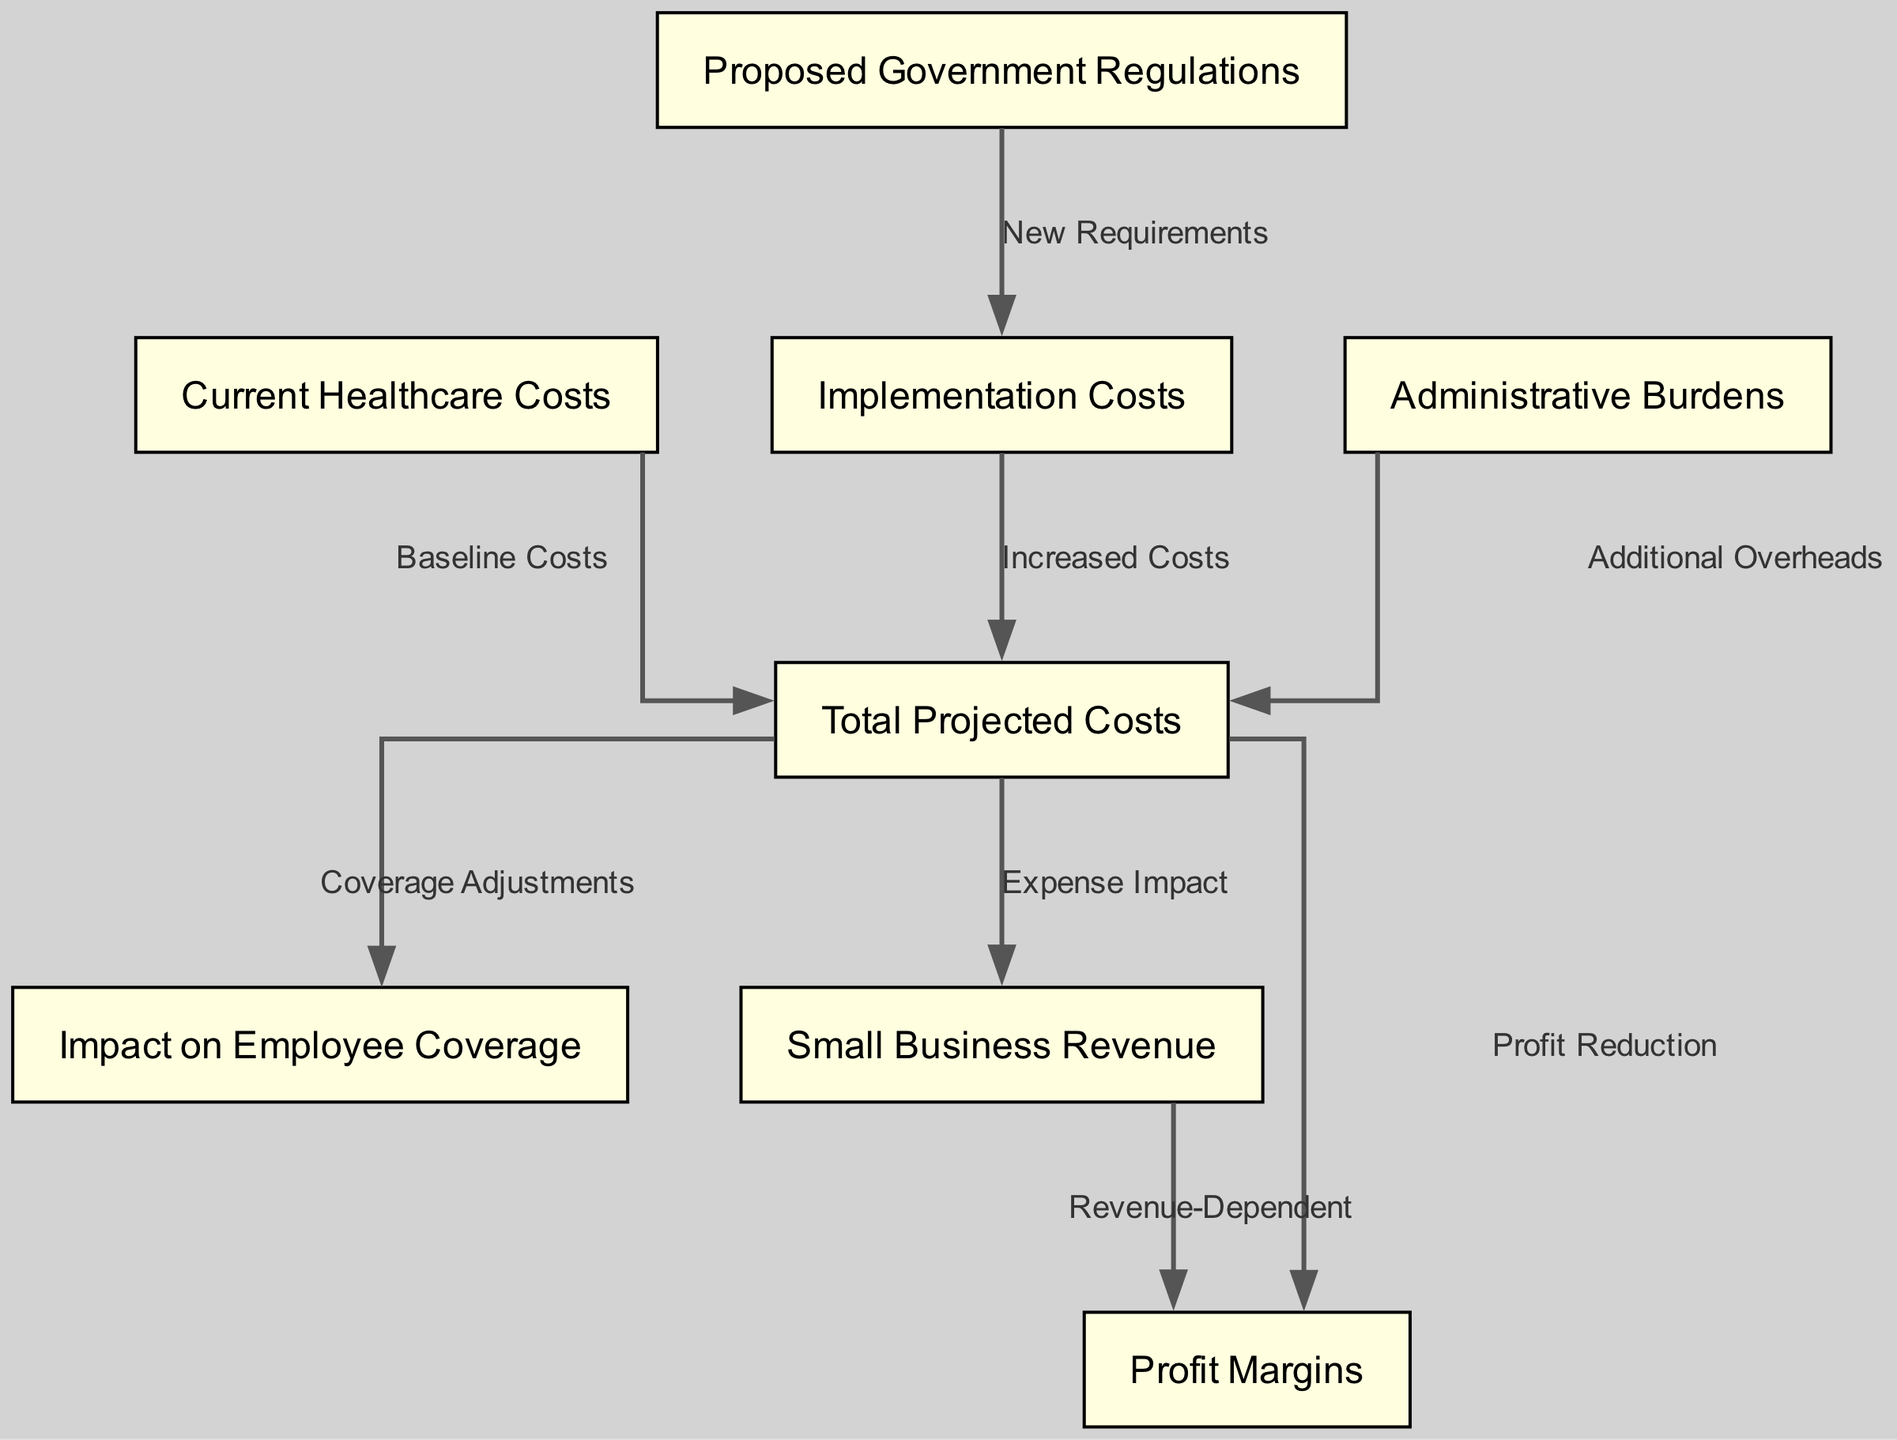What are the three main components leading to total projected costs? The diagram shows that total projected costs arise from current healthcare costs and the implementation costs from proposed government regulations and administrative burdens.
Answer: Current healthcare costs, implementation costs, administrative burdens How many nodes are present in the diagram? By counting the nodes listed in the diagram structure, we find there are eight distinct nodes represented.
Answer: Eight What does "new requirements" connect to in the diagram? The label "new requirements" indicates a connection from proposed government regulations to implementation costs, showing a direct relationship.
Answer: Implementation costs Which node signifies the adjustments made in employee coverage? The total projected costs feed into the "impact on employee coverage," indicating that adjustments occur as a result of total projected costs.
Answer: Impact on employee coverage How do increased costs affect total projected costs? Increased costs, which stem from implementation costs, directly contribute to the rise in total projected costs. This shows the flow of expense from implementation to total costs.
Answer: Increased costs What is the relationship between total projected costs and profit margins? The diagram illustrates that total projected costs lead to profit reduction, which in turn impacts profit margins, establishing a chain of financial consequences.
Answer: Profit reduction Which edge represents additional overheads in relation to total costs? The edge labeled "additional overheads" connects administrative burdens to total projected costs, revealing a source of extra expenses.
Answer: Administrative burdens What impacts small business revenue according to the diagram? The "expense impact" edge from total projected costs to small business revenue shows that total costs affect revenue generation in small businesses.
Answer: Expense impact Which node is identified as the baseline for current healthcare costs? The arrow from current healthcare costs to total projected costs indicates that current expenses serve as a foundational figure in calculating overall costs.
Answer: Current healthcare costs 